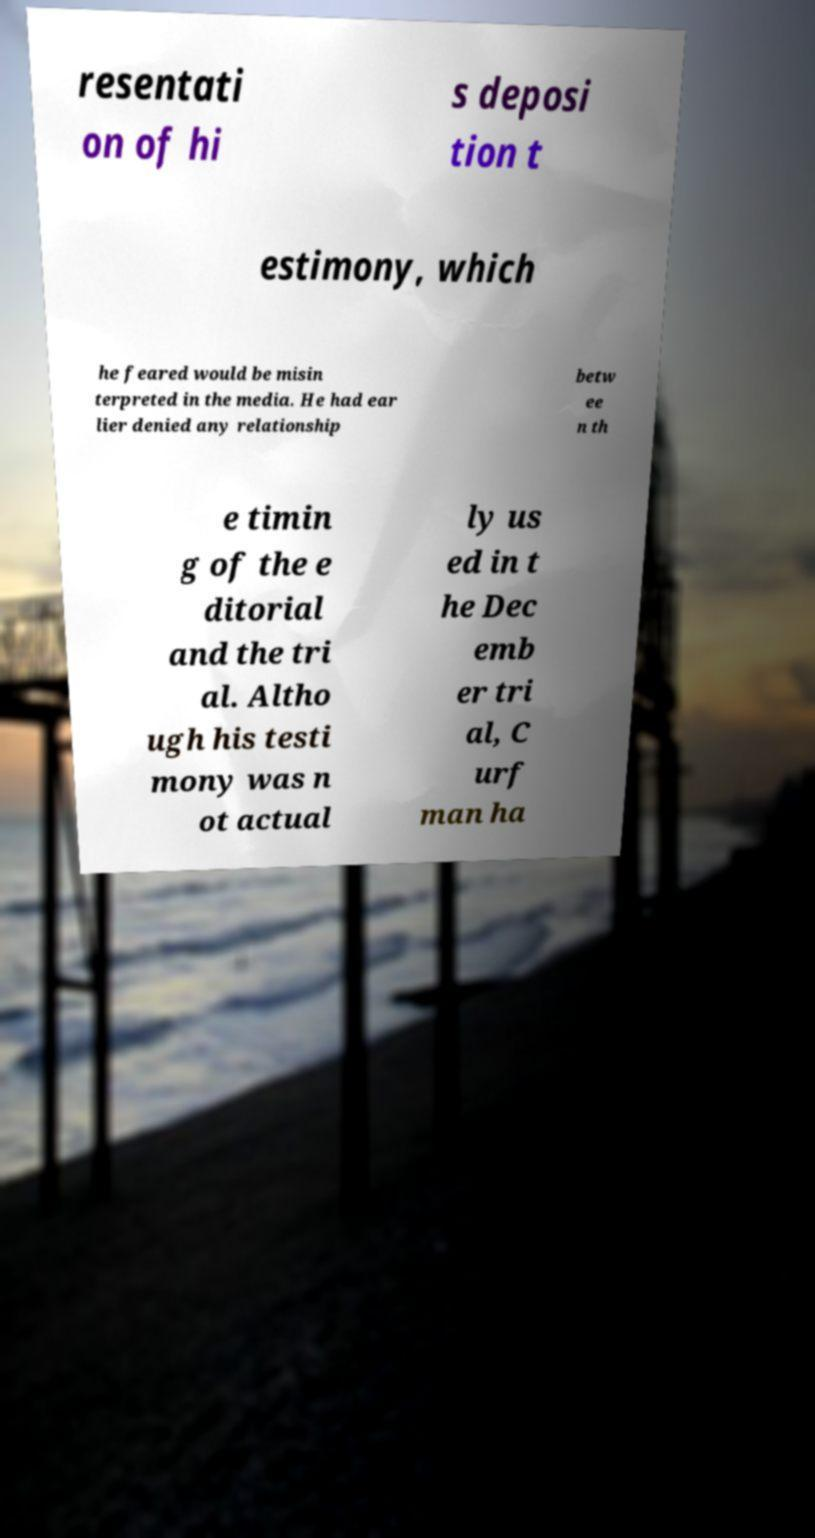Can you accurately transcribe the text from the provided image for me? resentati on of hi s deposi tion t estimony, which he feared would be misin terpreted in the media. He had ear lier denied any relationship betw ee n th e timin g of the e ditorial and the tri al. Altho ugh his testi mony was n ot actual ly us ed in t he Dec emb er tri al, C urf man ha 